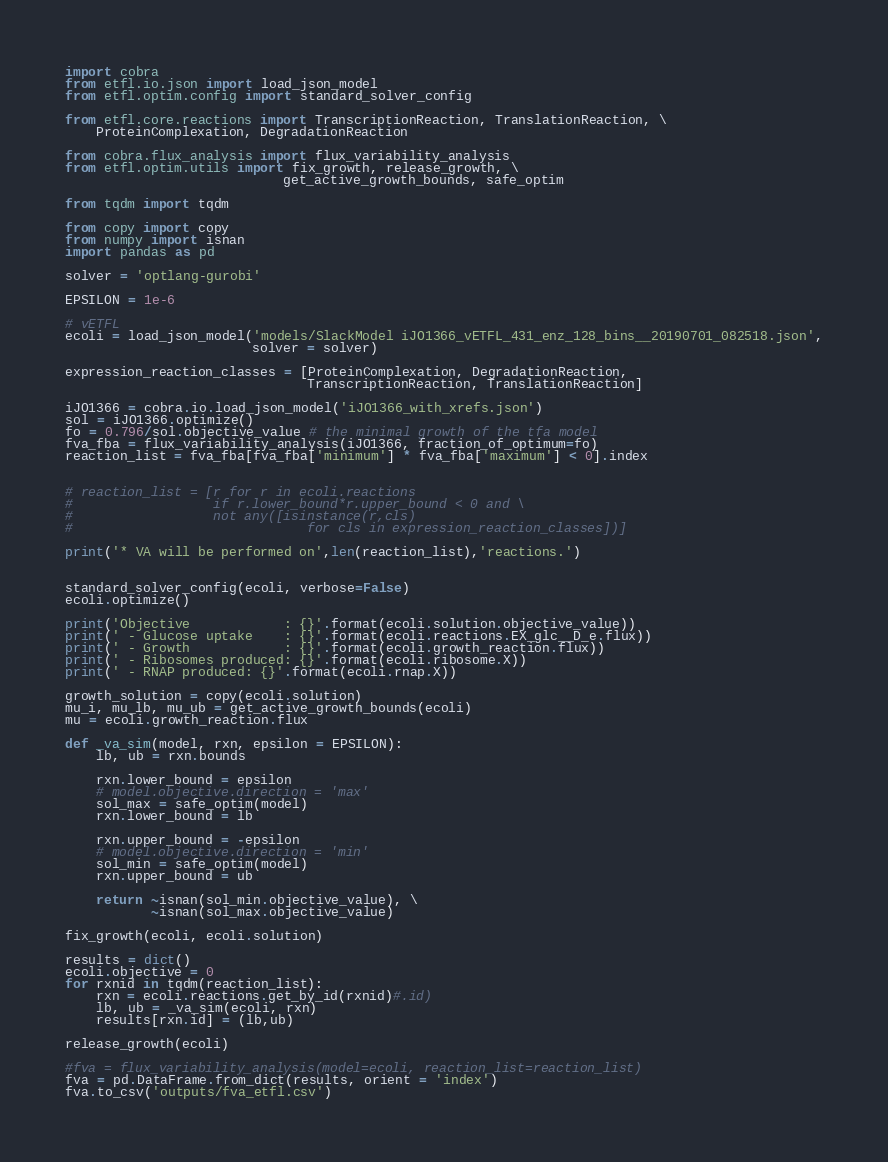<code> <loc_0><loc_0><loc_500><loc_500><_Python_>import cobra
from etfl.io.json import load_json_model
from etfl.optim.config import standard_solver_config

from etfl.core.reactions import TranscriptionReaction, TranslationReaction, \
    ProteinComplexation, DegradationReaction

from cobra.flux_analysis import flux_variability_analysis
from etfl.optim.utils import fix_growth, release_growth, \
                            get_active_growth_bounds, safe_optim

from tqdm import tqdm

from copy import copy
from numpy import isnan
import pandas as pd

solver = 'optlang-gurobi'

EPSILON = 1e-6

# vETFL
ecoli = load_json_model('models/SlackModel iJO1366_vETFL_431_enz_128_bins__20190701_082518.json',
                        solver = solver)

expression_reaction_classes = [ProteinComplexation, DegradationReaction,
                               TranscriptionReaction, TranslationReaction]

iJO1366 = cobra.io.load_json_model('iJO1366_with_xrefs.json')
sol = iJO1366.optimize()
fo = 0.796/sol.objective_value # the minimal growth of the tfa model
fva_fba = flux_variability_analysis(iJO1366, fraction_of_optimum=fo)
reaction_list = fva_fba[fva_fba['minimum'] * fva_fba['maximum'] < 0].index


# reaction_list = [r for r in ecoli.reactions
#                  if r.lower_bound*r.upper_bound < 0 and \
#                  not any([isinstance(r,cls)
#                              for cls in expression_reaction_classes])]

print('* VA will be performed on',len(reaction_list),'reactions.')


standard_solver_config(ecoli, verbose=False)
ecoli.optimize()

print('Objective            : {}'.format(ecoli.solution.objective_value))
print(' - Glucose uptake    : {}'.format(ecoli.reactions.EX_glc__D_e.flux))
print(' - Growth            : {}'.format(ecoli.growth_reaction.flux))
print(' - Ribosomes produced: {}'.format(ecoli.ribosome.X))
print(' - RNAP produced: {}'.format(ecoli.rnap.X))

growth_solution = copy(ecoli.solution)
mu_i, mu_lb, mu_ub = get_active_growth_bounds(ecoli)
mu = ecoli.growth_reaction.flux

def _va_sim(model, rxn, epsilon = EPSILON):
    lb, ub = rxn.bounds

    rxn.lower_bound = epsilon
    # model.objective.direction = 'max'
    sol_max = safe_optim(model)
    rxn.lower_bound = lb

    rxn.upper_bound = -epsilon
    # model.objective.direction = 'min'
    sol_min = safe_optim(model)
    rxn.upper_bound = ub

    return ~isnan(sol_min.objective_value), \
           ~isnan(sol_max.objective_value)

fix_growth(ecoli, ecoli.solution)

results = dict()
ecoli.objective = 0
for rxnid in tqdm(reaction_list):
    rxn = ecoli.reactions.get_by_id(rxnid)#.id)
    lb, ub = _va_sim(ecoli, rxn)
    results[rxn.id] = (lb,ub)

release_growth(ecoli)

#fva = flux_variability_analysis(model=ecoli, reaction_list=reaction_list)
fva = pd.DataFrame.from_dict(results, orient = 'index')
fva.to_csv('outputs/fva_etfl.csv')</code> 